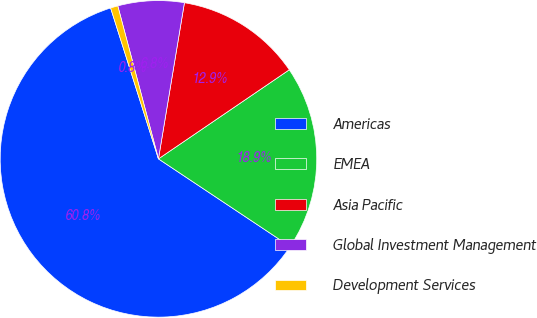<chart> <loc_0><loc_0><loc_500><loc_500><pie_chart><fcel>Americas<fcel>EMEA<fcel>Asia Pacific<fcel>Global Investment Management<fcel>Development Services<nl><fcel>60.76%<fcel>18.86%<fcel>12.86%<fcel>6.76%<fcel>0.75%<nl></chart> 